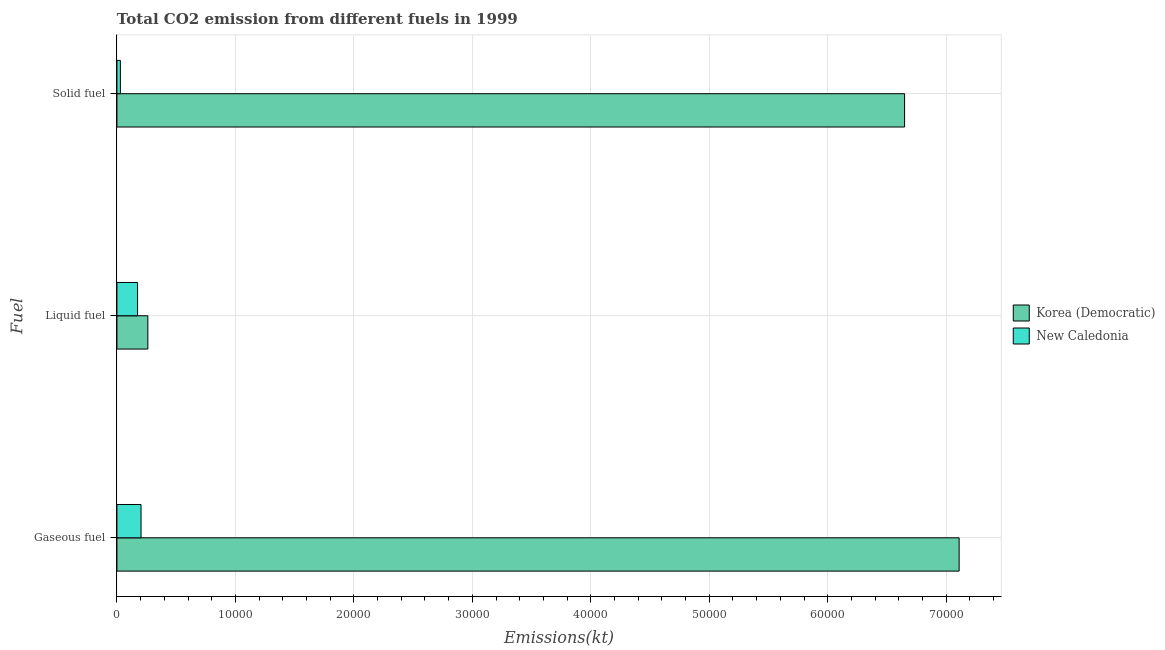Are the number of bars per tick equal to the number of legend labels?
Keep it short and to the point. Yes. How many bars are there on the 3rd tick from the bottom?
Your answer should be compact. 2. What is the label of the 2nd group of bars from the top?
Ensure brevity in your answer.  Liquid fuel. What is the amount of co2 emissions from gaseous fuel in New Caledonia?
Give a very brief answer. 2035.18. Across all countries, what is the maximum amount of co2 emissions from gaseous fuel?
Offer a very short reply. 7.11e+04. Across all countries, what is the minimum amount of co2 emissions from liquid fuel?
Give a very brief answer. 1741.83. In which country was the amount of co2 emissions from gaseous fuel maximum?
Make the answer very short. Korea (Democratic). In which country was the amount of co2 emissions from gaseous fuel minimum?
Keep it short and to the point. New Caledonia. What is the total amount of co2 emissions from solid fuel in the graph?
Offer a very short reply. 6.68e+04. What is the difference between the amount of co2 emissions from solid fuel in New Caledonia and that in Korea (Democratic)?
Your response must be concise. -6.62e+04. What is the difference between the amount of co2 emissions from liquid fuel in New Caledonia and the amount of co2 emissions from solid fuel in Korea (Democratic)?
Your answer should be compact. -6.47e+04. What is the average amount of co2 emissions from gaseous fuel per country?
Ensure brevity in your answer.  3.66e+04. What is the difference between the amount of co2 emissions from liquid fuel and amount of co2 emissions from gaseous fuel in Korea (Democratic)?
Your answer should be very brief. -6.85e+04. In how many countries, is the amount of co2 emissions from liquid fuel greater than 24000 kt?
Keep it short and to the point. 0. What is the ratio of the amount of co2 emissions from liquid fuel in Korea (Democratic) to that in New Caledonia?
Provide a short and direct response. 1.5. What is the difference between the highest and the second highest amount of co2 emissions from solid fuel?
Offer a terse response. 6.62e+04. What is the difference between the highest and the lowest amount of co2 emissions from solid fuel?
Provide a short and direct response. 6.62e+04. What does the 2nd bar from the top in Solid fuel represents?
Make the answer very short. Korea (Democratic). What does the 1st bar from the bottom in Gaseous fuel represents?
Offer a very short reply. Korea (Democratic). Is it the case that in every country, the sum of the amount of co2 emissions from gaseous fuel and amount of co2 emissions from liquid fuel is greater than the amount of co2 emissions from solid fuel?
Offer a very short reply. Yes. How many countries are there in the graph?
Provide a succinct answer. 2. What is the difference between two consecutive major ticks on the X-axis?
Offer a very short reply. 10000. Does the graph contain any zero values?
Your answer should be very brief. No. Does the graph contain grids?
Your answer should be compact. Yes. Where does the legend appear in the graph?
Give a very brief answer. Center right. How are the legend labels stacked?
Offer a very short reply. Vertical. What is the title of the graph?
Provide a short and direct response. Total CO2 emission from different fuels in 1999. Does "Kazakhstan" appear as one of the legend labels in the graph?
Provide a succinct answer. No. What is the label or title of the X-axis?
Give a very brief answer. Emissions(kt). What is the label or title of the Y-axis?
Your response must be concise. Fuel. What is the Emissions(kt) of Korea (Democratic) in Gaseous fuel?
Ensure brevity in your answer.  7.11e+04. What is the Emissions(kt) in New Caledonia in Gaseous fuel?
Your response must be concise. 2035.18. What is the Emissions(kt) in Korea (Democratic) in Liquid fuel?
Keep it short and to the point. 2610.9. What is the Emissions(kt) of New Caledonia in Liquid fuel?
Make the answer very short. 1741.83. What is the Emissions(kt) in Korea (Democratic) in Solid fuel?
Your response must be concise. 6.65e+04. What is the Emissions(kt) of New Caledonia in Solid fuel?
Your answer should be compact. 293.36. Across all Fuel, what is the maximum Emissions(kt) of Korea (Democratic)?
Ensure brevity in your answer.  7.11e+04. Across all Fuel, what is the maximum Emissions(kt) of New Caledonia?
Your response must be concise. 2035.18. Across all Fuel, what is the minimum Emissions(kt) in Korea (Democratic)?
Your answer should be very brief. 2610.9. Across all Fuel, what is the minimum Emissions(kt) of New Caledonia?
Provide a succinct answer. 293.36. What is the total Emissions(kt) in Korea (Democratic) in the graph?
Keep it short and to the point. 1.40e+05. What is the total Emissions(kt) of New Caledonia in the graph?
Provide a succinct answer. 4070.37. What is the difference between the Emissions(kt) in Korea (Democratic) in Gaseous fuel and that in Liquid fuel?
Provide a short and direct response. 6.85e+04. What is the difference between the Emissions(kt) in New Caledonia in Gaseous fuel and that in Liquid fuel?
Your response must be concise. 293.36. What is the difference between the Emissions(kt) in Korea (Democratic) in Gaseous fuel and that in Solid fuel?
Offer a terse response. 4605.75. What is the difference between the Emissions(kt) in New Caledonia in Gaseous fuel and that in Solid fuel?
Provide a succinct answer. 1741.83. What is the difference between the Emissions(kt) of Korea (Democratic) in Liquid fuel and that in Solid fuel?
Give a very brief answer. -6.39e+04. What is the difference between the Emissions(kt) in New Caledonia in Liquid fuel and that in Solid fuel?
Offer a terse response. 1448.46. What is the difference between the Emissions(kt) of Korea (Democratic) in Gaseous fuel and the Emissions(kt) of New Caledonia in Liquid fuel?
Your answer should be very brief. 6.94e+04. What is the difference between the Emissions(kt) in Korea (Democratic) in Gaseous fuel and the Emissions(kt) in New Caledonia in Solid fuel?
Give a very brief answer. 7.08e+04. What is the difference between the Emissions(kt) in Korea (Democratic) in Liquid fuel and the Emissions(kt) in New Caledonia in Solid fuel?
Provide a short and direct response. 2317.54. What is the average Emissions(kt) in Korea (Democratic) per Fuel?
Make the answer very short. 4.67e+04. What is the average Emissions(kt) of New Caledonia per Fuel?
Ensure brevity in your answer.  1356.79. What is the difference between the Emissions(kt) of Korea (Democratic) and Emissions(kt) of New Caledonia in Gaseous fuel?
Your answer should be compact. 6.91e+04. What is the difference between the Emissions(kt) of Korea (Democratic) and Emissions(kt) of New Caledonia in Liquid fuel?
Your answer should be compact. 869.08. What is the difference between the Emissions(kt) of Korea (Democratic) and Emissions(kt) of New Caledonia in Solid fuel?
Offer a very short reply. 6.62e+04. What is the ratio of the Emissions(kt) of Korea (Democratic) in Gaseous fuel to that in Liquid fuel?
Provide a short and direct response. 27.23. What is the ratio of the Emissions(kt) in New Caledonia in Gaseous fuel to that in Liquid fuel?
Your response must be concise. 1.17. What is the ratio of the Emissions(kt) in Korea (Democratic) in Gaseous fuel to that in Solid fuel?
Your answer should be compact. 1.07. What is the ratio of the Emissions(kt) of New Caledonia in Gaseous fuel to that in Solid fuel?
Your answer should be very brief. 6.94. What is the ratio of the Emissions(kt) of Korea (Democratic) in Liquid fuel to that in Solid fuel?
Offer a terse response. 0.04. What is the ratio of the Emissions(kt) in New Caledonia in Liquid fuel to that in Solid fuel?
Provide a succinct answer. 5.94. What is the difference between the highest and the second highest Emissions(kt) in Korea (Democratic)?
Keep it short and to the point. 4605.75. What is the difference between the highest and the second highest Emissions(kt) in New Caledonia?
Make the answer very short. 293.36. What is the difference between the highest and the lowest Emissions(kt) in Korea (Democratic)?
Offer a terse response. 6.85e+04. What is the difference between the highest and the lowest Emissions(kt) of New Caledonia?
Ensure brevity in your answer.  1741.83. 